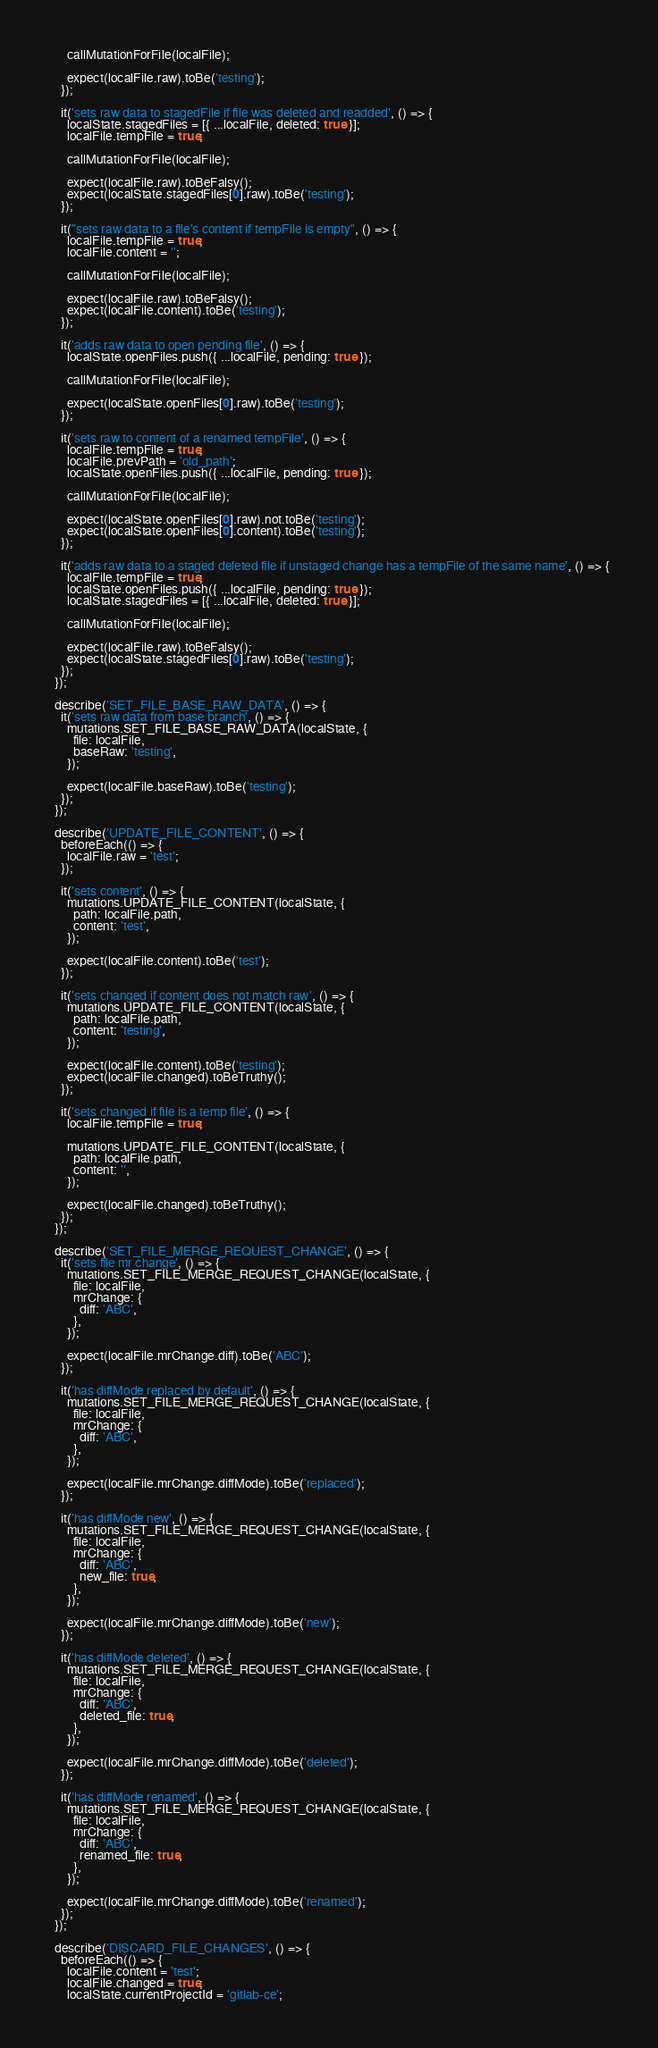Convert code to text. <code><loc_0><loc_0><loc_500><loc_500><_JavaScript_>      callMutationForFile(localFile);

      expect(localFile.raw).toBe('testing');
    });

    it('sets raw data to stagedFile if file was deleted and readded', () => {
      localState.stagedFiles = [{ ...localFile, deleted: true }];
      localFile.tempFile = true;

      callMutationForFile(localFile);

      expect(localFile.raw).toBeFalsy();
      expect(localState.stagedFiles[0].raw).toBe('testing');
    });

    it("sets raw data to a file's content if tempFile is empty", () => {
      localFile.tempFile = true;
      localFile.content = '';

      callMutationForFile(localFile);

      expect(localFile.raw).toBeFalsy();
      expect(localFile.content).toBe('testing');
    });

    it('adds raw data to open pending file', () => {
      localState.openFiles.push({ ...localFile, pending: true });

      callMutationForFile(localFile);

      expect(localState.openFiles[0].raw).toBe('testing');
    });

    it('sets raw to content of a renamed tempFile', () => {
      localFile.tempFile = true;
      localFile.prevPath = 'old_path';
      localState.openFiles.push({ ...localFile, pending: true });

      callMutationForFile(localFile);

      expect(localState.openFiles[0].raw).not.toBe('testing');
      expect(localState.openFiles[0].content).toBe('testing');
    });

    it('adds raw data to a staged deleted file if unstaged change has a tempFile of the same name', () => {
      localFile.tempFile = true;
      localState.openFiles.push({ ...localFile, pending: true });
      localState.stagedFiles = [{ ...localFile, deleted: true }];

      callMutationForFile(localFile);

      expect(localFile.raw).toBeFalsy();
      expect(localState.stagedFiles[0].raw).toBe('testing');
    });
  });

  describe('SET_FILE_BASE_RAW_DATA', () => {
    it('sets raw data from base branch', () => {
      mutations.SET_FILE_BASE_RAW_DATA(localState, {
        file: localFile,
        baseRaw: 'testing',
      });

      expect(localFile.baseRaw).toBe('testing');
    });
  });

  describe('UPDATE_FILE_CONTENT', () => {
    beforeEach(() => {
      localFile.raw = 'test';
    });

    it('sets content', () => {
      mutations.UPDATE_FILE_CONTENT(localState, {
        path: localFile.path,
        content: 'test',
      });

      expect(localFile.content).toBe('test');
    });

    it('sets changed if content does not match raw', () => {
      mutations.UPDATE_FILE_CONTENT(localState, {
        path: localFile.path,
        content: 'testing',
      });

      expect(localFile.content).toBe('testing');
      expect(localFile.changed).toBeTruthy();
    });

    it('sets changed if file is a temp file', () => {
      localFile.tempFile = true;

      mutations.UPDATE_FILE_CONTENT(localState, {
        path: localFile.path,
        content: '',
      });

      expect(localFile.changed).toBeTruthy();
    });
  });

  describe('SET_FILE_MERGE_REQUEST_CHANGE', () => {
    it('sets file mr change', () => {
      mutations.SET_FILE_MERGE_REQUEST_CHANGE(localState, {
        file: localFile,
        mrChange: {
          diff: 'ABC',
        },
      });

      expect(localFile.mrChange.diff).toBe('ABC');
    });

    it('has diffMode replaced by default', () => {
      mutations.SET_FILE_MERGE_REQUEST_CHANGE(localState, {
        file: localFile,
        mrChange: {
          diff: 'ABC',
        },
      });

      expect(localFile.mrChange.diffMode).toBe('replaced');
    });

    it('has diffMode new', () => {
      mutations.SET_FILE_MERGE_REQUEST_CHANGE(localState, {
        file: localFile,
        mrChange: {
          diff: 'ABC',
          new_file: true,
        },
      });

      expect(localFile.mrChange.diffMode).toBe('new');
    });

    it('has diffMode deleted', () => {
      mutations.SET_FILE_MERGE_REQUEST_CHANGE(localState, {
        file: localFile,
        mrChange: {
          diff: 'ABC',
          deleted_file: true,
        },
      });

      expect(localFile.mrChange.diffMode).toBe('deleted');
    });

    it('has diffMode renamed', () => {
      mutations.SET_FILE_MERGE_REQUEST_CHANGE(localState, {
        file: localFile,
        mrChange: {
          diff: 'ABC',
          renamed_file: true,
        },
      });

      expect(localFile.mrChange.diffMode).toBe('renamed');
    });
  });

  describe('DISCARD_FILE_CHANGES', () => {
    beforeEach(() => {
      localFile.content = 'test';
      localFile.changed = true;
      localState.currentProjectId = 'gitlab-ce';</code> 